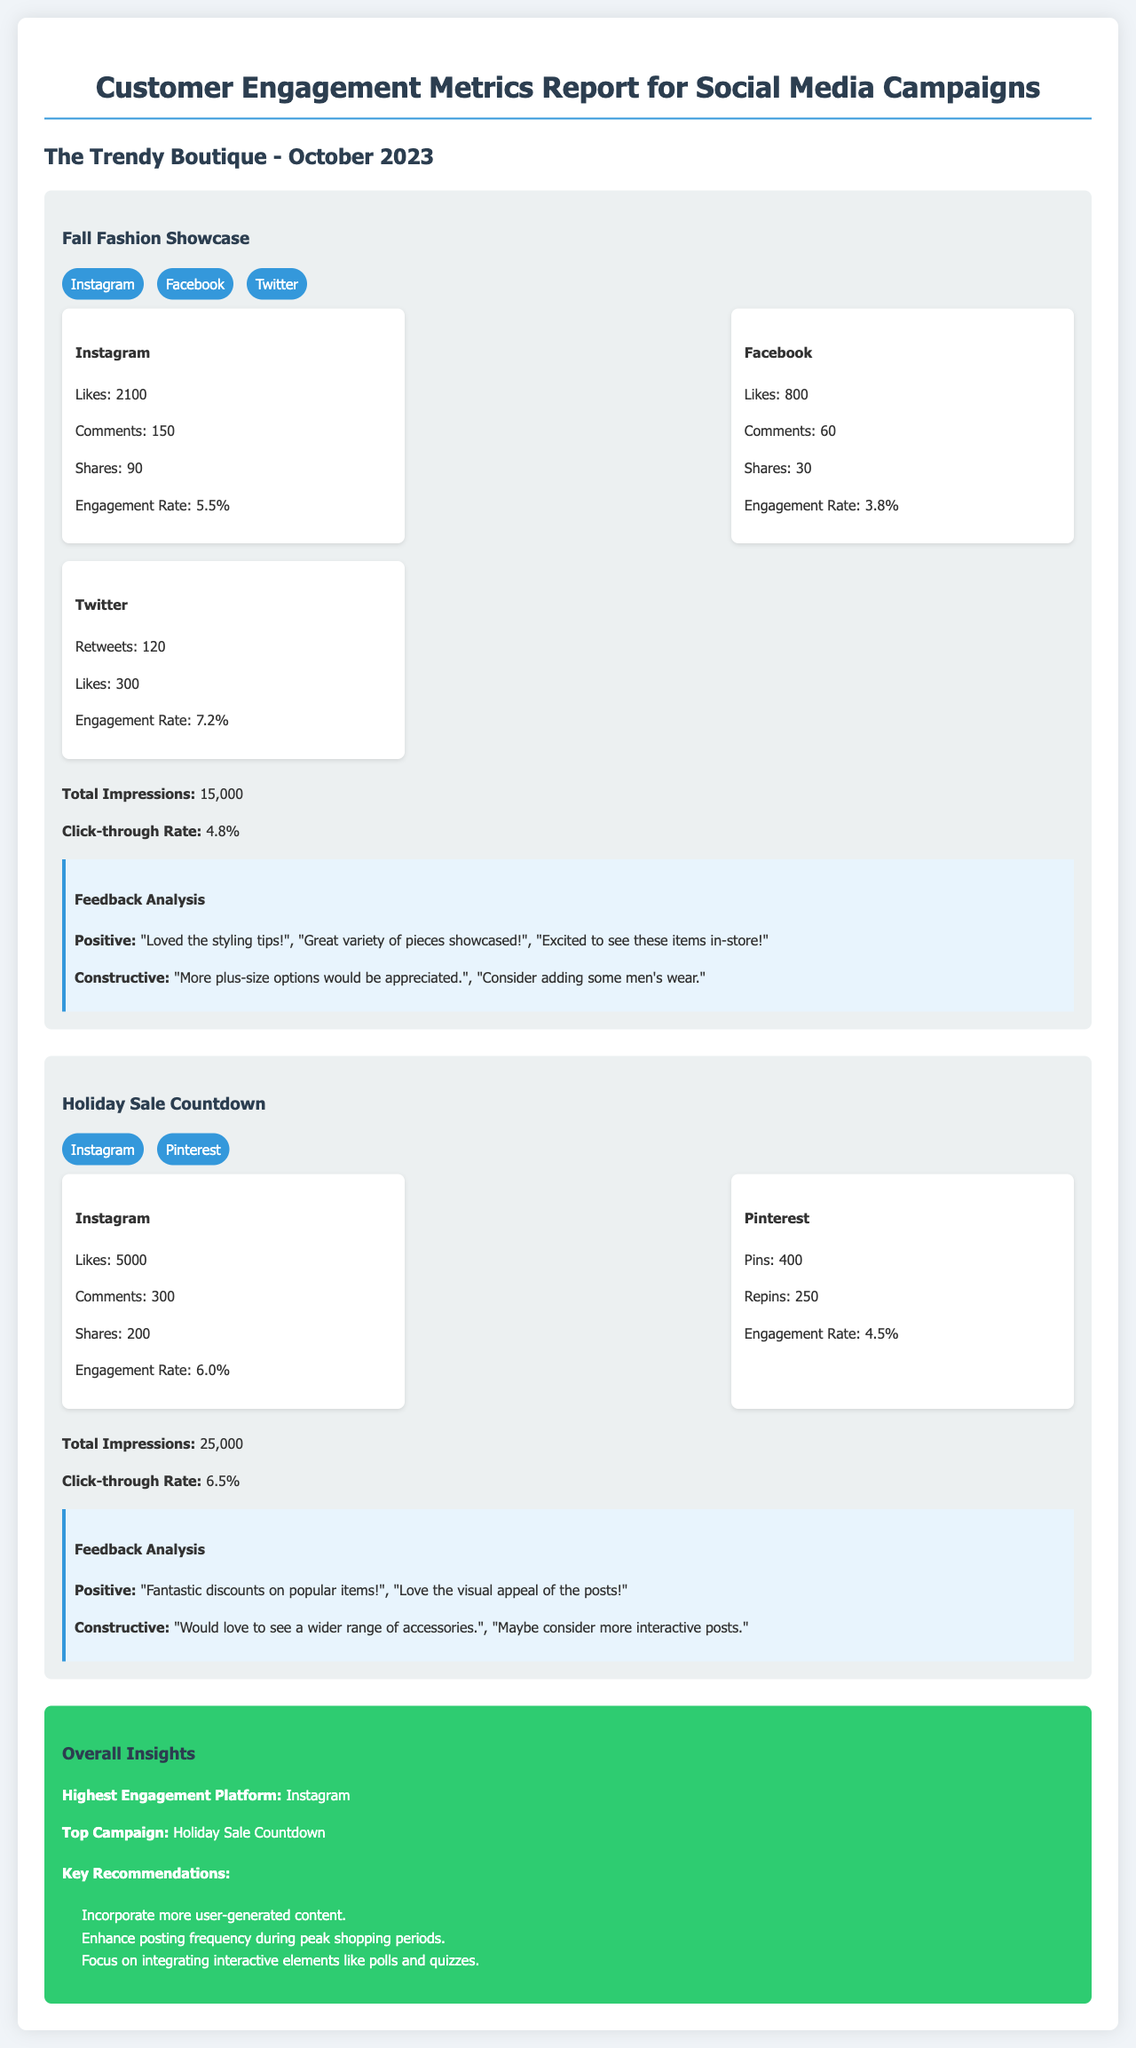What is the engagement rate for Instagram in the Fall Fashion Showcase? The engagement rate is a specific metric mentioned for Instagram in the Fall Fashion Showcase campaign.
Answer: 5.5% How many total impressions did the Holiday Sale Countdown campaign receive? The total impressions are explicitly stated for the Holiday Sale Countdown campaign.
Answer: 25,000 What positive feedback was received for the Fall Fashion Showcase? Positive feedback contains customer comments regarding the Fall Fashion Showcase that are included in the feedback analysis section.
Answer: "Loved the styling tips!" What is the total number of comments on Instagram for the Holiday Sale Countdown? The specific number of comments for Instagram in the Holiday Sale Countdown campaign is listed in the metrics.
Answer: 300 Which social media platform had the highest engagement rate overall? The overall insights section highlights the highest engagement platform based on campaign performance.
Answer: Instagram What is the click-through rate for the Fall Fashion Showcase? The click-through rate is provided in the metrics for the Fall Fashion Showcase campaign.
Answer: 4.8% What constructive feedback was provided for the Holiday Sale Countdown? Constructive feedback mentions customer suggestions, and this is included in the feedback analysis.
Answer: "Would love to see a wider range of accessories." What is the title of the report? The title that appears at the top of the document clearly identifies what the report is about.
Answer: Customer Engagement Metrics Report for Social Media Campaigns Which campaign had the most likes on Instagram? The comparison of likes across Instagram campaigns highlights which one performed the best.
Answer: Holiday Sale Countdown 